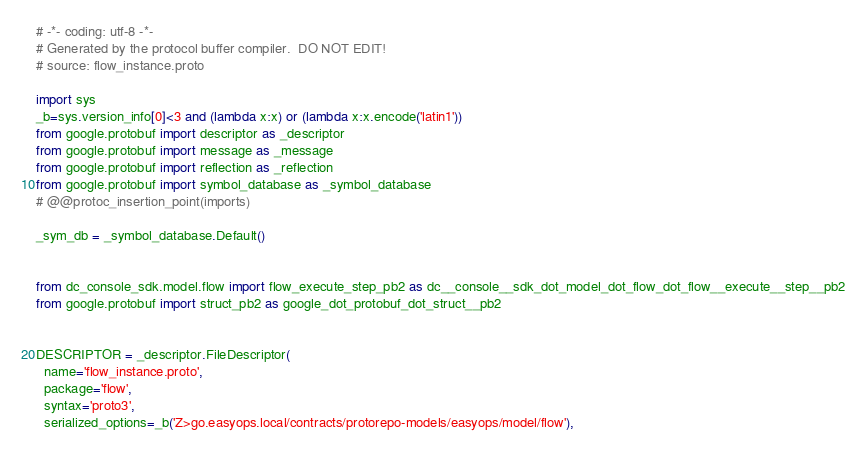<code> <loc_0><loc_0><loc_500><loc_500><_Python_># -*- coding: utf-8 -*-
# Generated by the protocol buffer compiler.  DO NOT EDIT!
# source: flow_instance.proto

import sys
_b=sys.version_info[0]<3 and (lambda x:x) or (lambda x:x.encode('latin1'))
from google.protobuf import descriptor as _descriptor
from google.protobuf import message as _message
from google.protobuf import reflection as _reflection
from google.protobuf import symbol_database as _symbol_database
# @@protoc_insertion_point(imports)

_sym_db = _symbol_database.Default()


from dc_console_sdk.model.flow import flow_execute_step_pb2 as dc__console__sdk_dot_model_dot_flow_dot_flow__execute__step__pb2
from google.protobuf import struct_pb2 as google_dot_protobuf_dot_struct__pb2


DESCRIPTOR = _descriptor.FileDescriptor(
  name='flow_instance.proto',
  package='flow',
  syntax='proto3',
  serialized_options=_b('Z>go.easyops.local/contracts/protorepo-models/easyops/model/flow'),</code> 